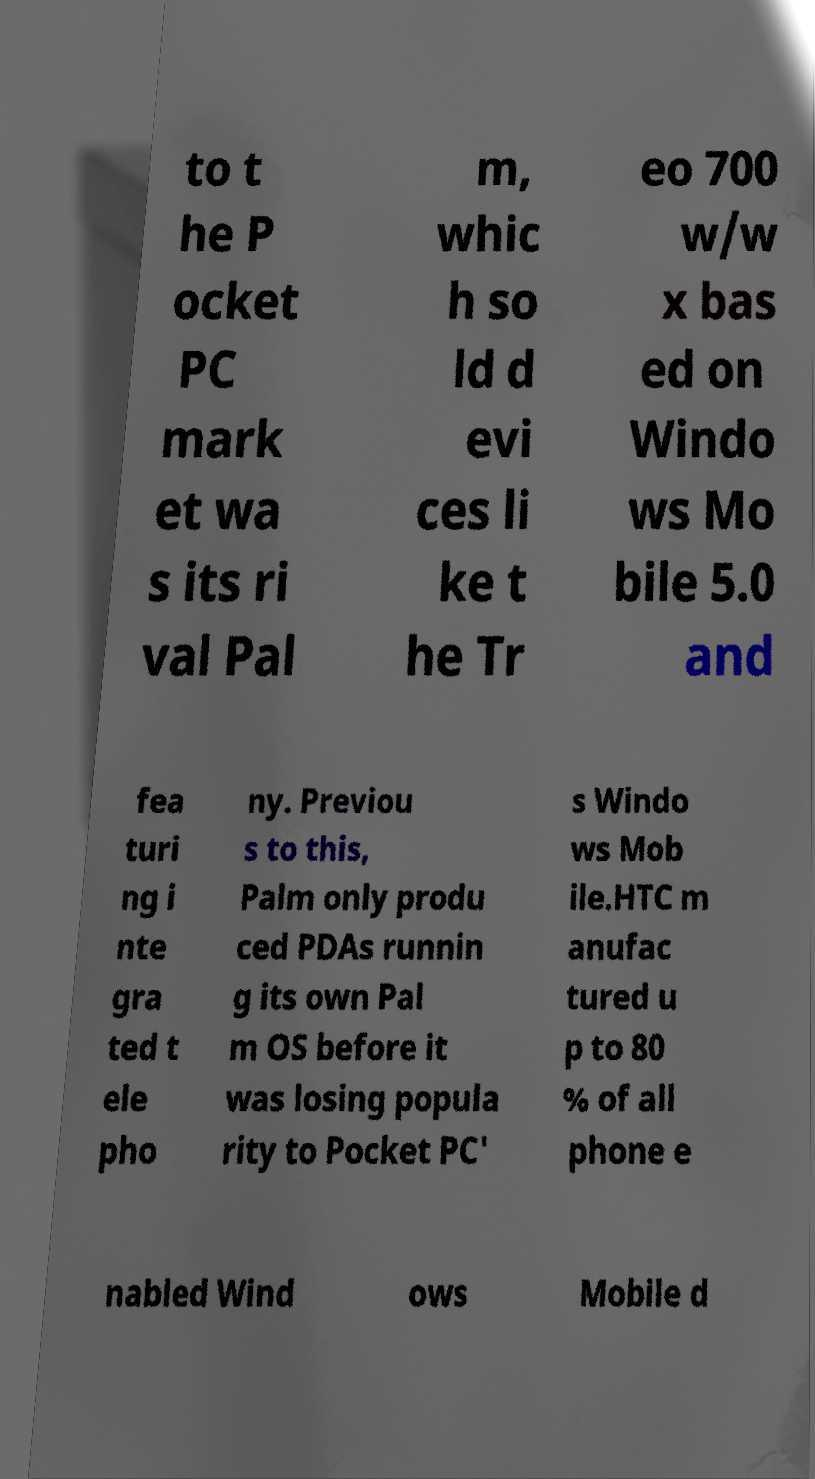What messages or text are displayed in this image? I need them in a readable, typed format. to t he P ocket PC mark et wa s its ri val Pal m, whic h so ld d evi ces li ke t he Tr eo 700 w/w x bas ed on Windo ws Mo bile 5.0 and fea turi ng i nte gra ted t ele pho ny. Previou s to this, Palm only produ ced PDAs runnin g its own Pal m OS before it was losing popula rity to Pocket PC' s Windo ws Mob ile.HTC m anufac tured u p to 80 % of all phone e nabled Wind ows Mobile d 